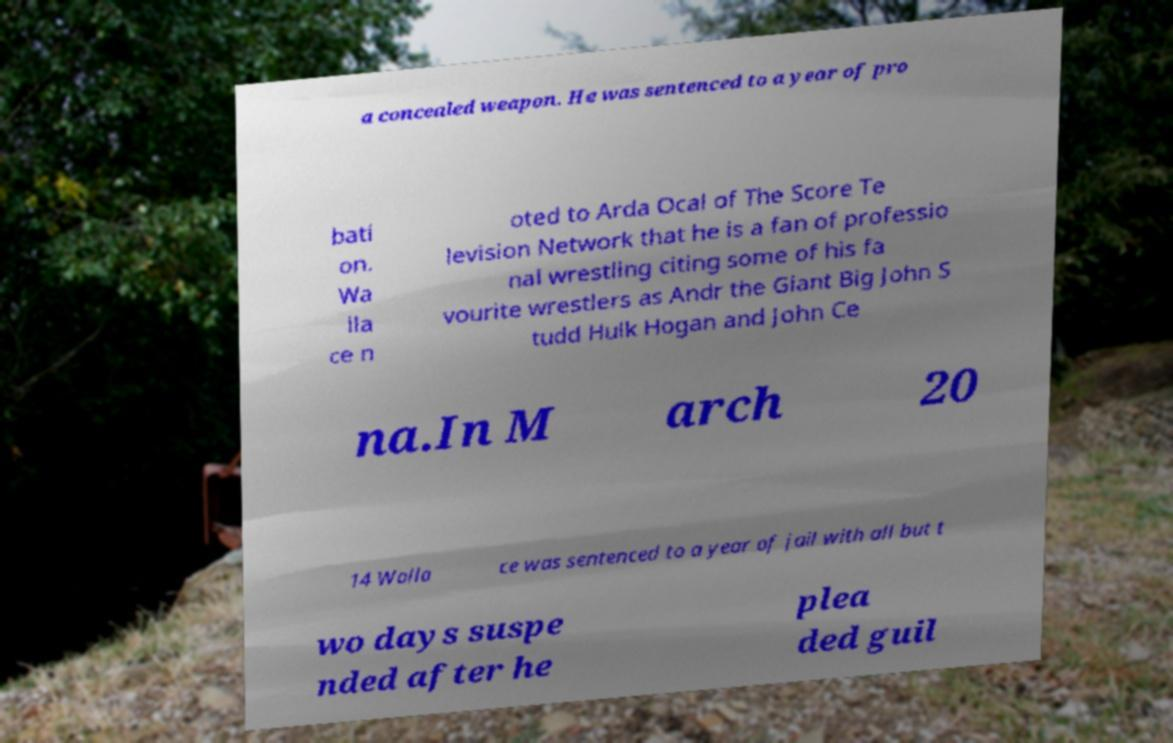Could you extract and type out the text from this image? a concealed weapon. He was sentenced to a year of pro bati on. Wa lla ce n oted to Arda Ocal of The Score Te levision Network that he is a fan of professio nal wrestling citing some of his fa vourite wrestlers as Andr the Giant Big John S tudd Hulk Hogan and John Ce na.In M arch 20 14 Walla ce was sentenced to a year of jail with all but t wo days suspe nded after he plea ded guil 